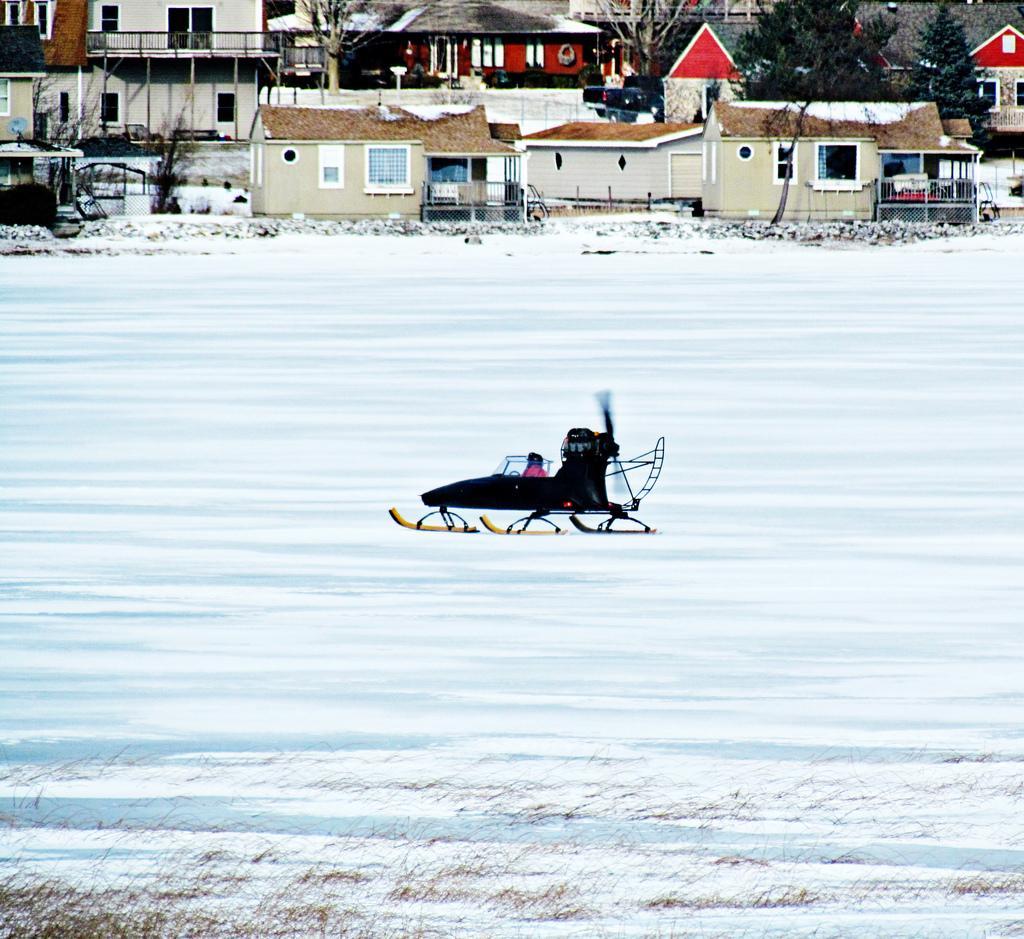Could you give a brief overview of what you see in this image? In this picture there is snow in the center of the image and there is roller skates in the center of the image, there are houses and trees at the top side of the image. 